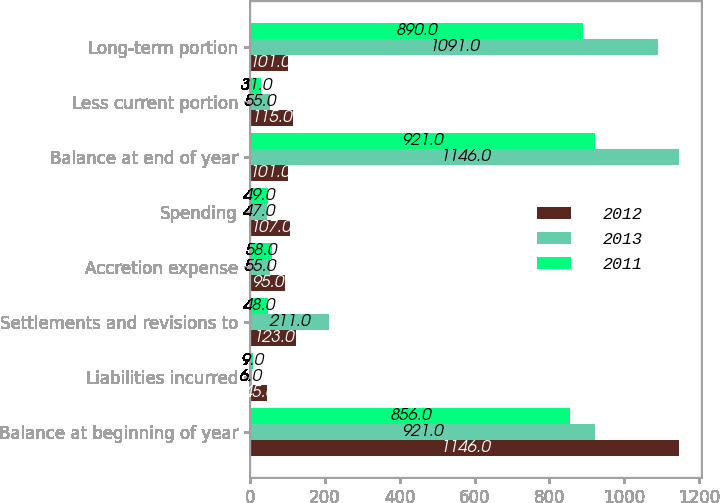<chart> <loc_0><loc_0><loc_500><loc_500><stacked_bar_chart><ecel><fcel>Balance at beginning of year<fcel>Liabilities incurred<fcel>Settlements and revisions to<fcel>Accretion expense<fcel>Spending<fcel>Balance at end of year<fcel>Less current portion<fcel>Long-term portion<nl><fcel>2012<fcel>1146<fcel>45<fcel>123<fcel>95<fcel>107<fcel>101<fcel>115<fcel>101<nl><fcel>2013<fcel>921<fcel>6<fcel>211<fcel>55<fcel>47<fcel>1146<fcel>55<fcel>1091<nl><fcel>2011<fcel>856<fcel>9<fcel>48<fcel>58<fcel>49<fcel>921<fcel>31<fcel>890<nl></chart> 